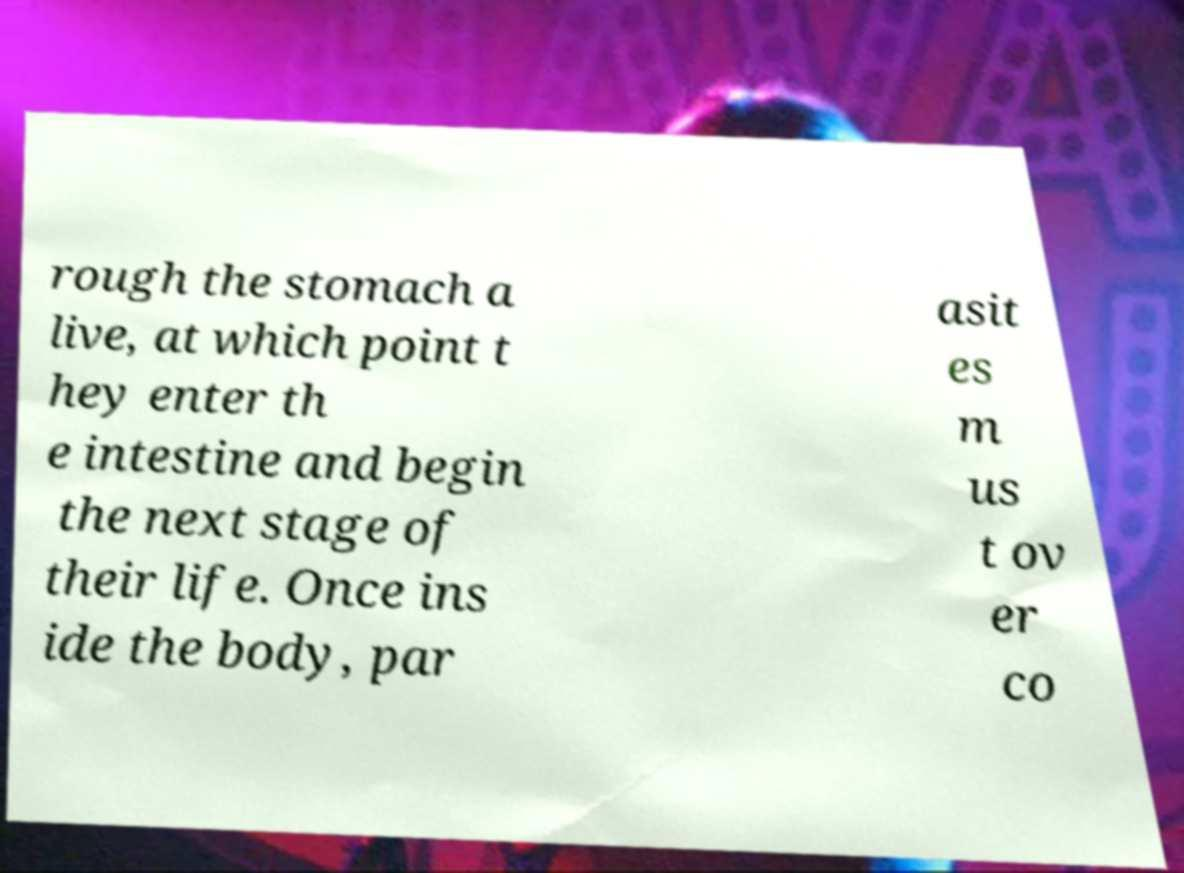Please identify and transcribe the text found in this image. rough the stomach a live, at which point t hey enter th e intestine and begin the next stage of their life. Once ins ide the body, par asit es m us t ov er co 